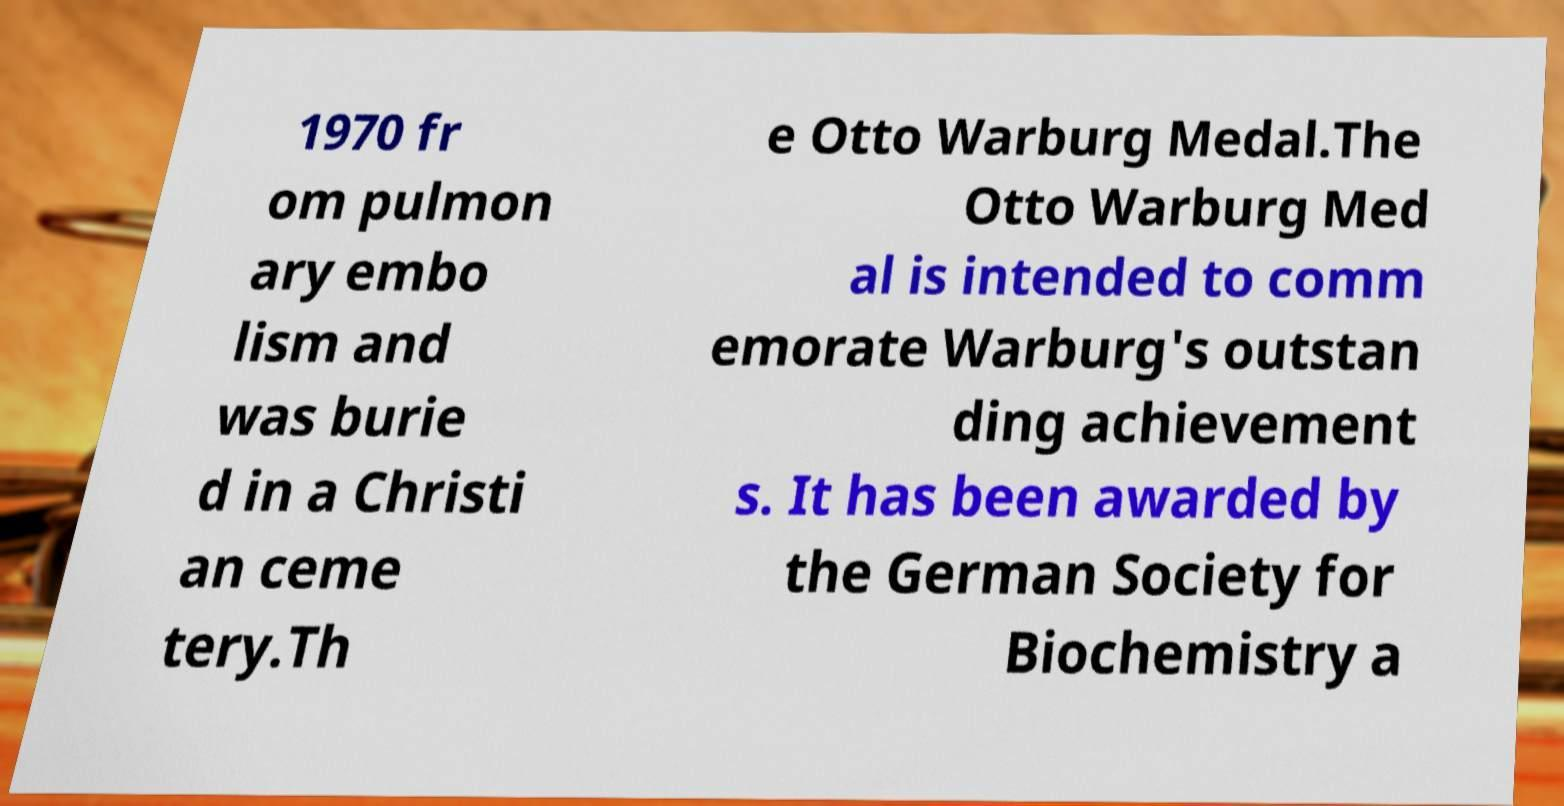There's text embedded in this image that I need extracted. Can you transcribe it verbatim? 1970 fr om pulmon ary embo lism and was burie d in a Christi an ceme tery.Th e Otto Warburg Medal.The Otto Warburg Med al is intended to comm emorate Warburg's outstan ding achievement s. It has been awarded by the German Society for Biochemistry a 